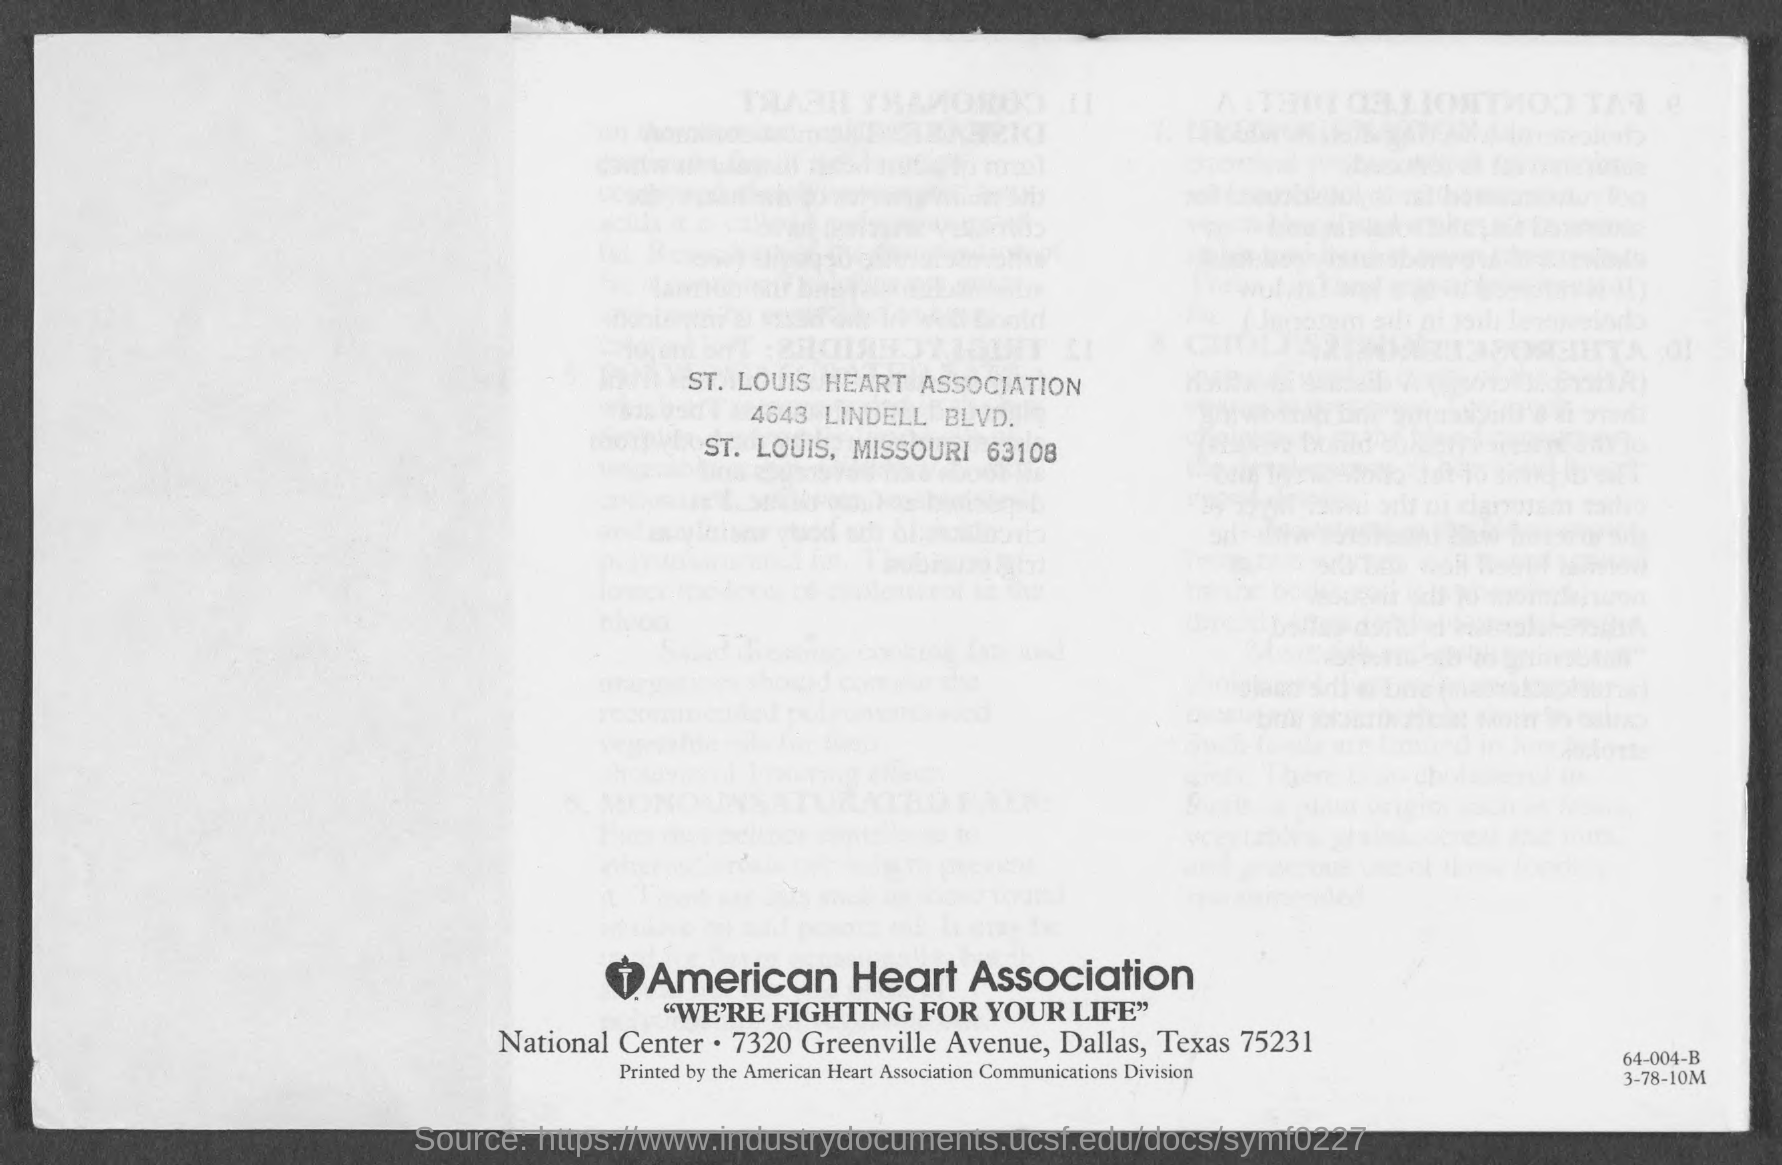Draw attention to some important aspects in this diagram. The American Heart Association is located in the state of Texas. The St. Louis Heart Association is located in the city of St. Louis. The American Heart Association's slogan is "We're Fighting for Your Life. 